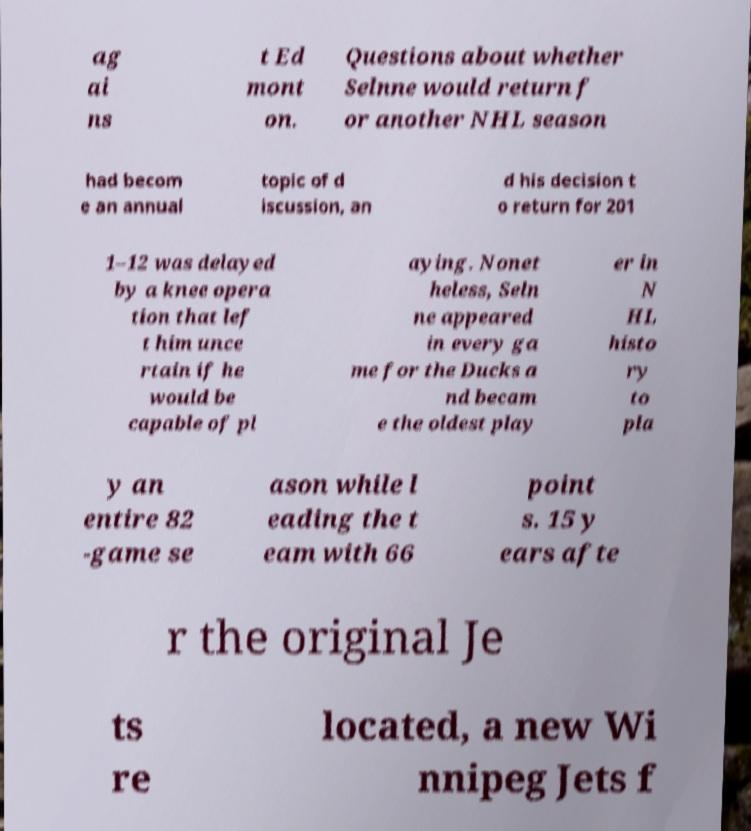Please identify and transcribe the text found in this image. ag ai ns t Ed mont on. Questions about whether Selnne would return f or another NHL season had becom e an annual topic of d iscussion, an d his decision t o return for 201 1–12 was delayed by a knee opera tion that lef t him unce rtain if he would be capable of pl aying. Nonet heless, Seln ne appeared in every ga me for the Ducks a nd becam e the oldest play er in N HL histo ry to pla y an entire 82 -game se ason while l eading the t eam with 66 point s. 15 y ears afte r the original Je ts re located, a new Wi nnipeg Jets f 